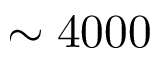Convert formula to latex. <formula><loc_0><loc_0><loc_500><loc_500>\sim 4 0 0 0</formula> 